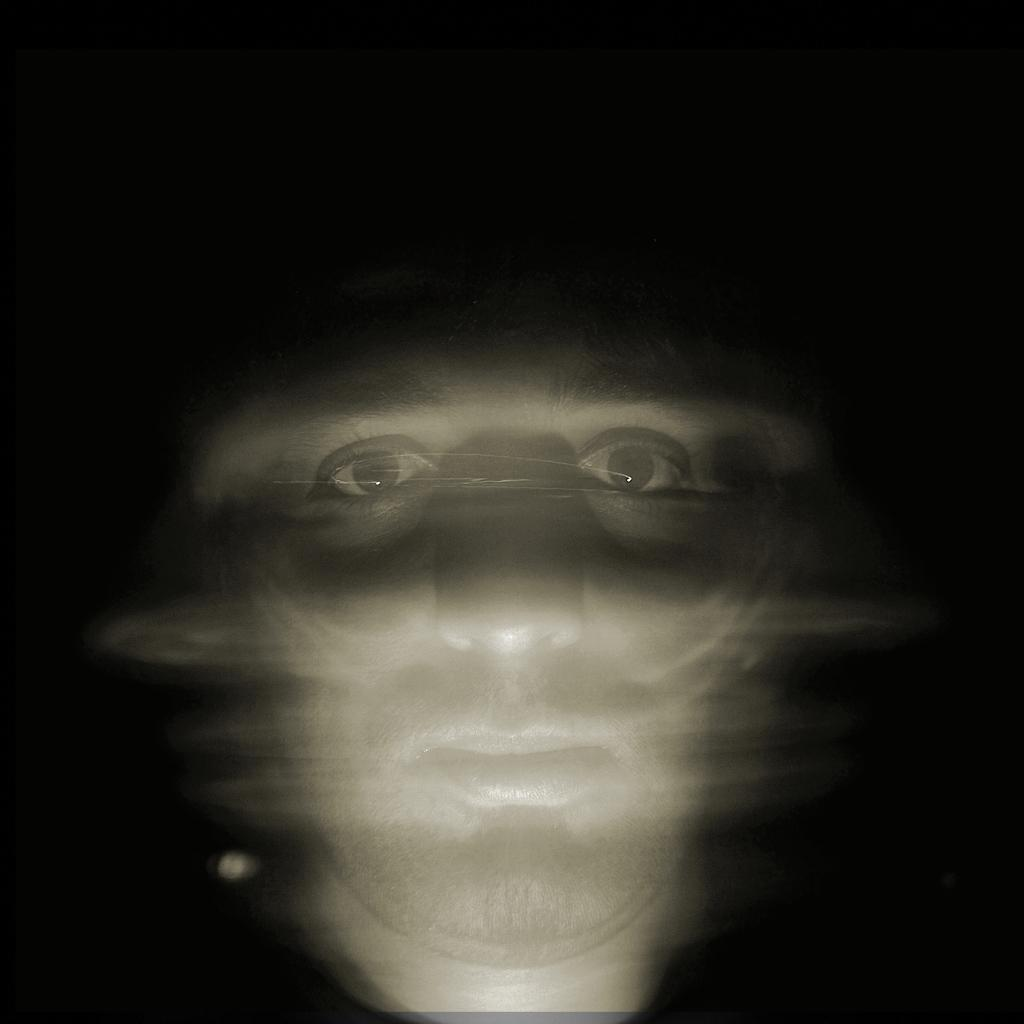What is the main subject of the image? The main subject of the image is a man's face. Can you describe the lighting or setting of the image? The image appears to be in a dark setting. What type of rhythm is the man's face displaying in the image? The man's face does not display any rhythm in the image; it is a still image of a face. 